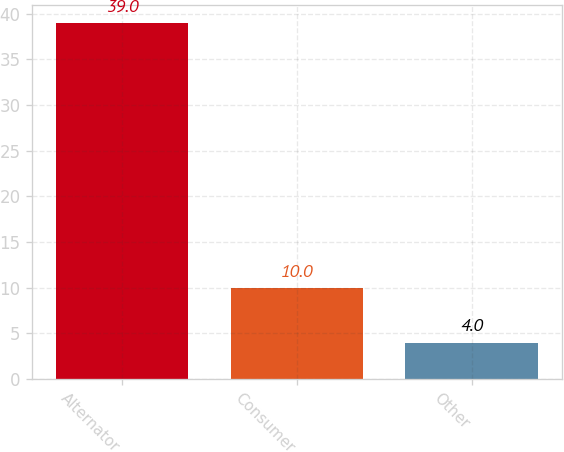Convert chart to OTSL. <chart><loc_0><loc_0><loc_500><loc_500><bar_chart><fcel>Alternator<fcel>Consumer<fcel>Other<nl><fcel>39<fcel>10<fcel>4<nl></chart> 